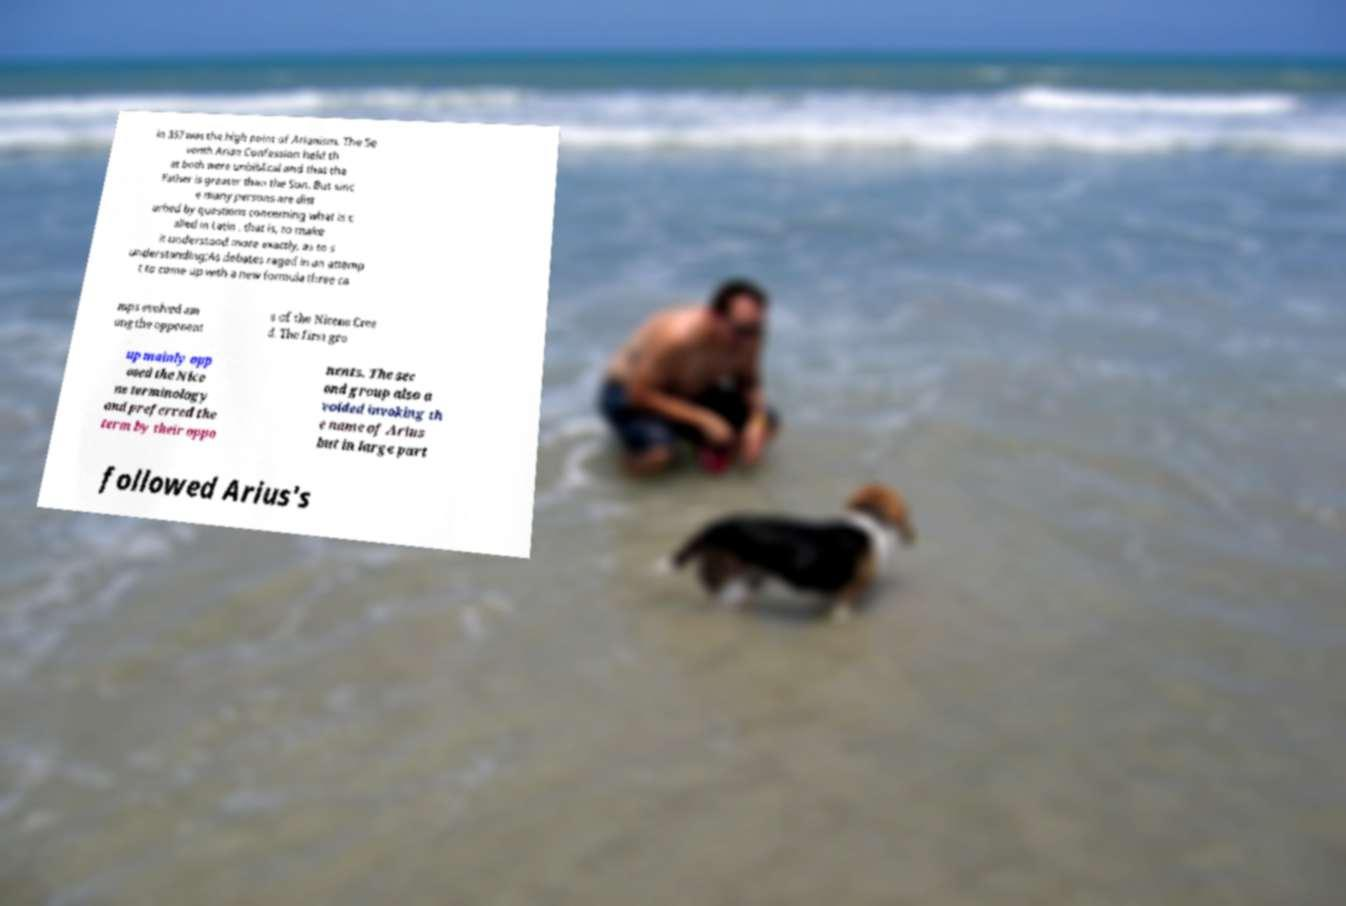I need the written content from this picture converted into text. Can you do that? in 357 was the high point of Arianism. The Se venth Arian Confession held th at both were unbiblical and that the Father is greater than the Son. But sinc e many persons are dist urbed by questions concerning what is c alled in Latin , that is, to make it understood more exactly, as to s understanding;As debates raged in an attemp t to come up with a new formula three ca mps evolved am ong the opponent s of the Nicene Cree d. The first gro up mainly opp osed the Nice ne terminology and preferred the term by their oppo nents. The sec ond group also a voided invoking th e name of Arius but in large part followed Arius's 